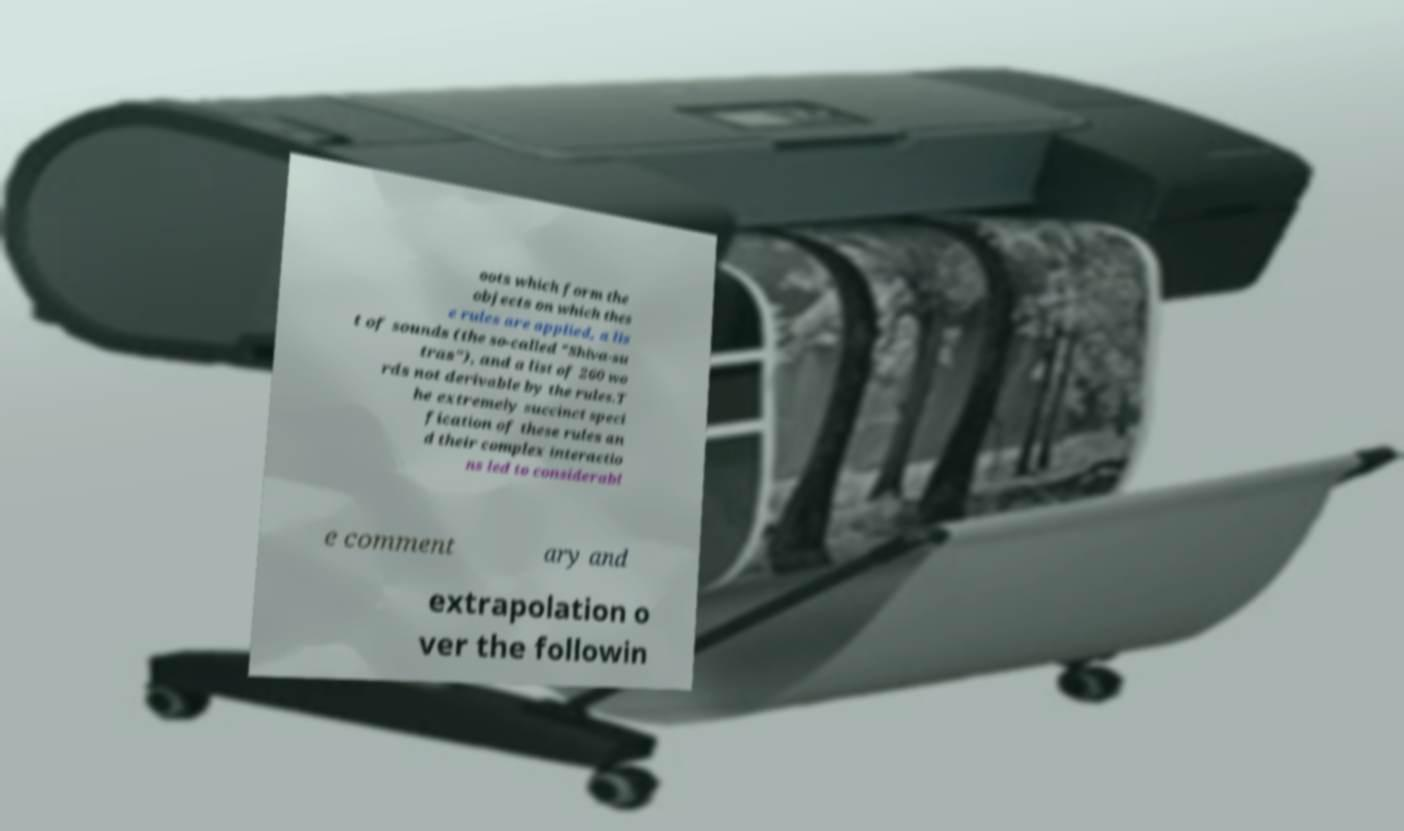Please identify and transcribe the text found in this image. oots which form the objects on which thes e rules are applied, a lis t of sounds (the so-called "Shiva-su tras"), and a list of 260 wo rds not derivable by the rules.T he extremely succinct speci fication of these rules an d their complex interactio ns led to considerabl e comment ary and extrapolation o ver the followin 